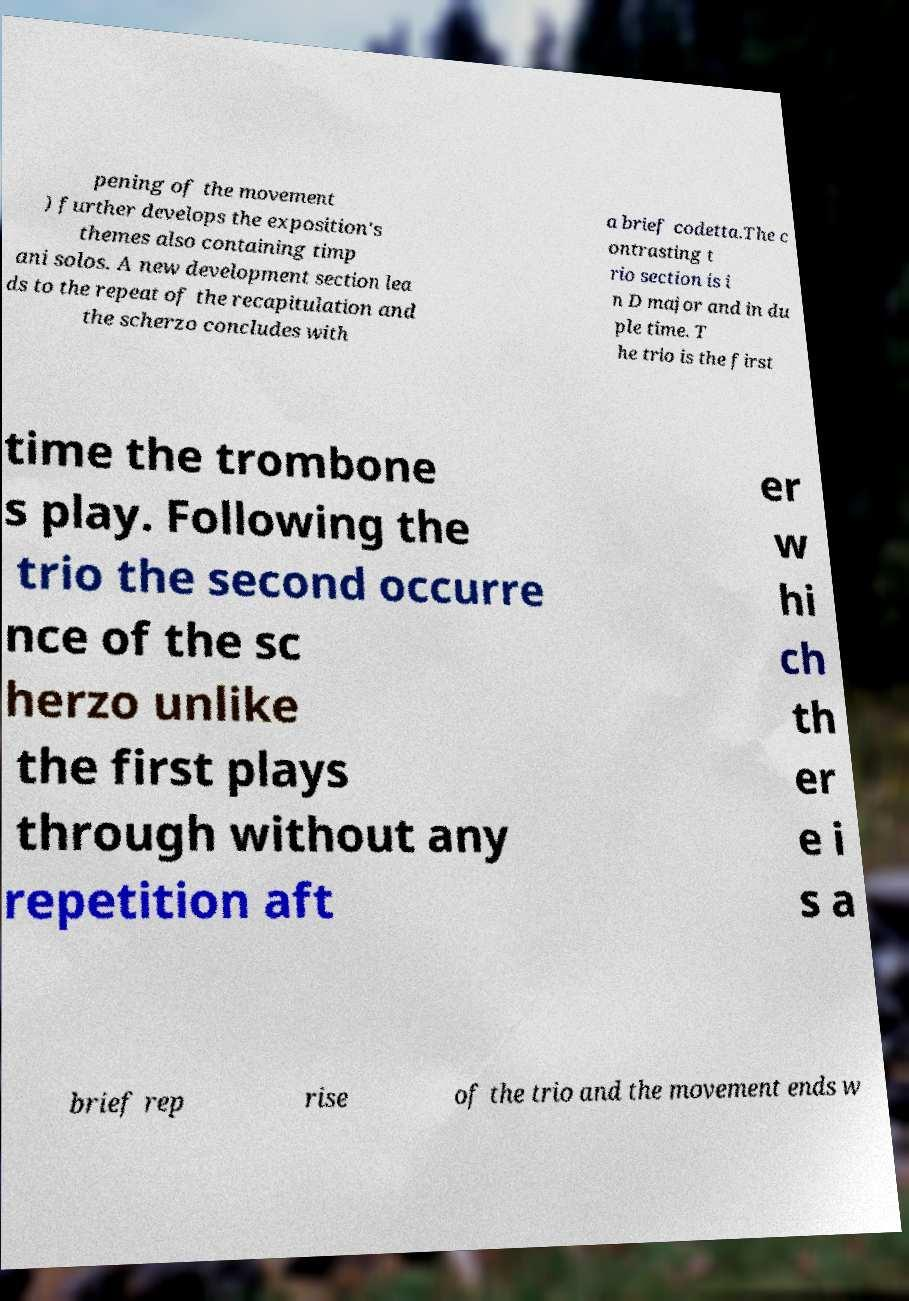Can you read and provide the text displayed in the image?This photo seems to have some interesting text. Can you extract and type it out for me? pening of the movement ) further develops the exposition's themes also containing timp ani solos. A new development section lea ds to the repeat of the recapitulation and the scherzo concludes with a brief codetta.The c ontrasting t rio section is i n D major and in du ple time. T he trio is the first time the trombone s play. Following the trio the second occurre nce of the sc herzo unlike the first plays through without any repetition aft er w hi ch th er e i s a brief rep rise of the trio and the movement ends w 